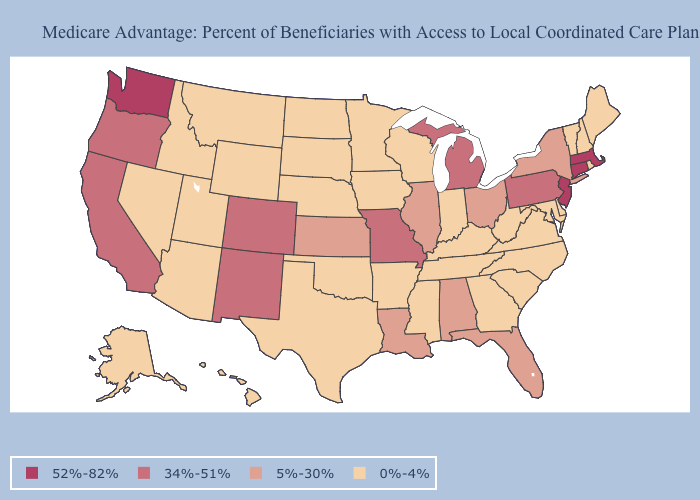How many symbols are there in the legend?
Be succinct. 4. What is the value of West Virginia?
Answer briefly. 0%-4%. Name the states that have a value in the range 0%-4%?
Answer briefly. Alaska, Arkansas, Arizona, Delaware, Georgia, Hawaii, Iowa, Idaho, Indiana, Kentucky, Maryland, Maine, Minnesota, Mississippi, Montana, North Carolina, North Dakota, Nebraska, New Hampshire, Nevada, Oklahoma, Rhode Island, South Carolina, South Dakota, Tennessee, Texas, Utah, Virginia, Vermont, Wisconsin, West Virginia, Wyoming. What is the value of Colorado?
Answer briefly. 34%-51%. What is the value of Indiana?
Keep it brief. 0%-4%. Does Iowa have a higher value than New Jersey?
Answer briefly. No. Name the states that have a value in the range 0%-4%?
Give a very brief answer. Alaska, Arkansas, Arizona, Delaware, Georgia, Hawaii, Iowa, Idaho, Indiana, Kentucky, Maryland, Maine, Minnesota, Mississippi, Montana, North Carolina, North Dakota, Nebraska, New Hampshire, Nevada, Oklahoma, Rhode Island, South Carolina, South Dakota, Tennessee, Texas, Utah, Virginia, Vermont, Wisconsin, West Virginia, Wyoming. Name the states that have a value in the range 0%-4%?
Write a very short answer. Alaska, Arkansas, Arizona, Delaware, Georgia, Hawaii, Iowa, Idaho, Indiana, Kentucky, Maryland, Maine, Minnesota, Mississippi, Montana, North Carolina, North Dakota, Nebraska, New Hampshire, Nevada, Oklahoma, Rhode Island, South Carolina, South Dakota, Tennessee, Texas, Utah, Virginia, Vermont, Wisconsin, West Virginia, Wyoming. Name the states that have a value in the range 5%-30%?
Be succinct. Alabama, Florida, Illinois, Kansas, Louisiana, New York, Ohio. Which states have the lowest value in the USA?
Short answer required. Alaska, Arkansas, Arizona, Delaware, Georgia, Hawaii, Iowa, Idaho, Indiana, Kentucky, Maryland, Maine, Minnesota, Mississippi, Montana, North Carolina, North Dakota, Nebraska, New Hampshire, Nevada, Oklahoma, Rhode Island, South Carolina, South Dakota, Tennessee, Texas, Utah, Virginia, Vermont, Wisconsin, West Virginia, Wyoming. Name the states that have a value in the range 34%-51%?
Write a very short answer. California, Colorado, Michigan, Missouri, New Mexico, Oregon, Pennsylvania. Does Rhode Island have the lowest value in the Northeast?
Short answer required. Yes. Does the first symbol in the legend represent the smallest category?
Quick response, please. No. Does Massachusetts have the highest value in the Northeast?
Answer briefly. Yes. Does the map have missing data?
Concise answer only. No. 